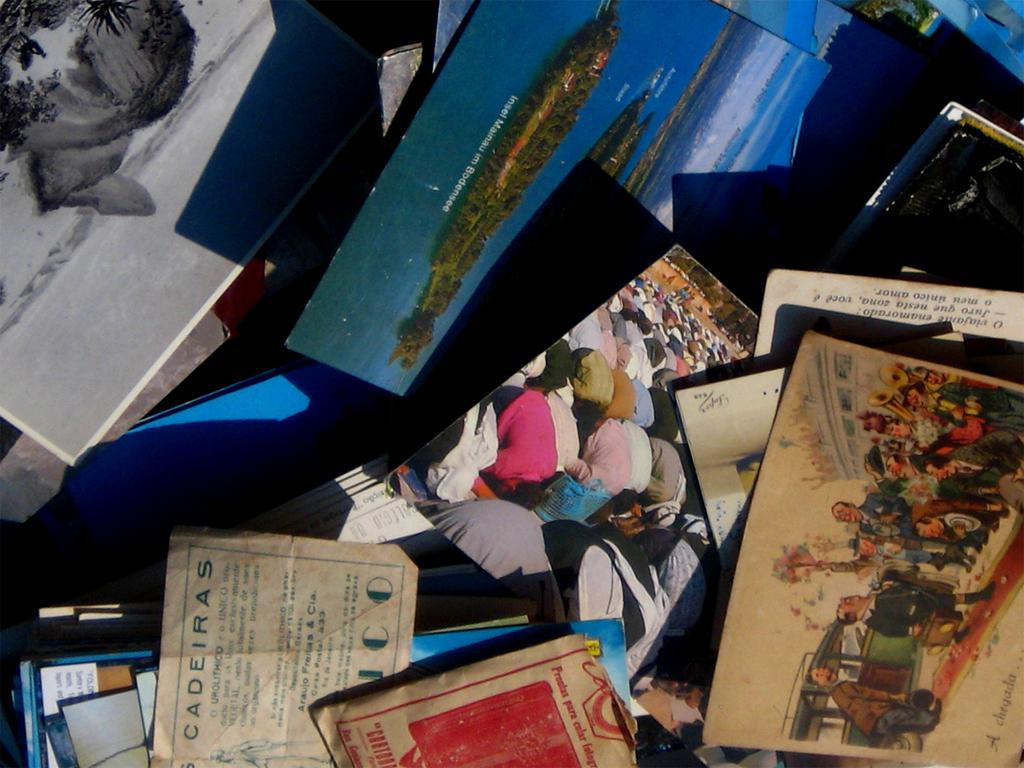What type of items can be seen in the image? There are photos, papers, and books in the image. Can you describe the papers in the image? The papers are flat and can be written or drawn on. What might the books be used for? The books might be used for reading or reference. What type of wire is used to hold the train in the image? There is no train present in the image; it only contains photos, papers, and books. 